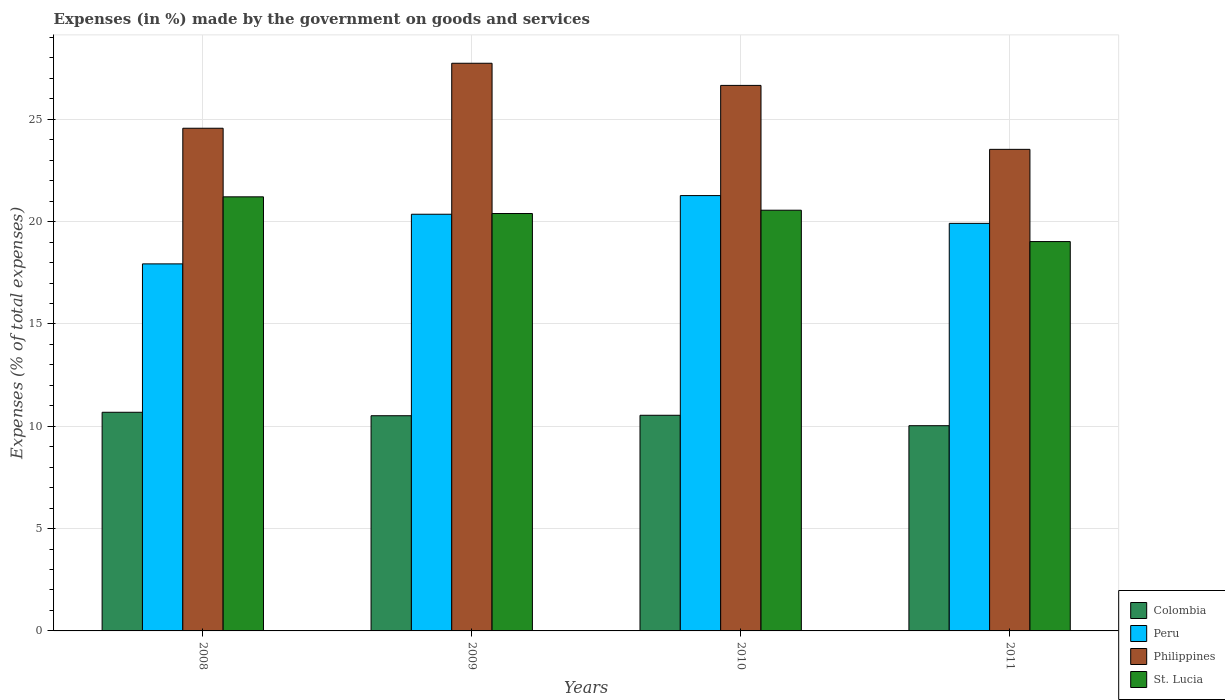Are the number of bars per tick equal to the number of legend labels?
Give a very brief answer. Yes. How many bars are there on the 1st tick from the left?
Your answer should be very brief. 4. How many bars are there on the 4th tick from the right?
Keep it short and to the point. 4. What is the label of the 4th group of bars from the left?
Provide a succinct answer. 2011. What is the percentage of expenses made by the government on goods and services in Colombia in 2008?
Provide a succinct answer. 10.69. Across all years, what is the maximum percentage of expenses made by the government on goods and services in Peru?
Your answer should be very brief. 21.28. Across all years, what is the minimum percentage of expenses made by the government on goods and services in Philippines?
Offer a very short reply. 23.54. What is the total percentage of expenses made by the government on goods and services in Peru in the graph?
Your response must be concise. 79.5. What is the difference between the percentage of expenses made by the government on goods and services in Philippines in 2009 and that in 2011?
Offer a very short reply. 4.21. What is the difference between the percentage of expenses made by the government on goods and services in Peru in 2011 and the percentage of expenses made by the government on goods and services in St. Lucia in 2010?
Provide a short and direct response. -0.64. What is the average percentage of expenses made by the government on goods and services in St. Lucia per year?
Provide a succinct answer. 20.3. In the year 2008, what is the difference between the percentage of expenses made by the government on goods and services in Philippines and percentage of expenses made by the government on goods and services in St. Lucia?
Your response must be concise. 3.35. In how many years, is the percentage of expenses made by the government on goods and services in Colombia greater than 17 %?
Provide a short and direct response. 0. What is the ratio of the percentage of expenses made by the government on goods and services in St. Lucia in 2008 to that in 2011?
Offer a terse response. 1.11. Is the percentage of expenses made by the government on goods and services in Colombia in 2008 less than that in 2009?
Offer a terse response. No. What is the difference between the highest and the second highest percentage of expenses made by the government on goods and services in Peru?
Provide a succinct answer. 0.91. What is the difference between the highest and the lowest percentage of expenses made by the government on goods and services in Philippines?
Your answer should be compact. 4.21. In how many years, is the percentage of expenses made by the government on goods and services in Peru greater than the average percentage of expenses made by the government on goods and services in Peru taken over all years?
Your response must be concise. 3. Is the sum of the percentage of expenses made by the government on goods and services in Peru in 2008 and 2010 greater than the maximum percentage of expenses made by the government on goods and services in St. Lucia across all years?
Keep it short and to the point. Yes. What does the 3rd bar from the right in 2008 represents?
Provide a short and direct response. Peru. Is it the case that in every year, the sum of the percentage of expenses made by the government on goods and services in Philippines and percentage of expenses made by the government on goods and services in St. Lucia is greater than the percentage of expenses made by the government on goods and services in Peru?
Make the answer very short. Yes. Are all the bars in the graph horizontal?
Offer a terse response. No. How many years are there in the graph?
Ensure brevity in your answer.  4. Does the graph contain any zero values?
Offer a very short reply. No. How many legend labels are there?
Keep it short and to the point. 4. What is the title of the graph?
Keep it short and to the point. Expenses (in %) made by the government on goods and services. What is the label or title of the Y-axis?
Make the answer very short. Expenses (% of total expenses). What is the Expenses (% of total expenses) in Colombia in 2008?
Your answer should be very brief. 10.69. What is the Expenses (% of total expenses) in Peru in 2008?
Offer a very short reply. 17.94. What is the Expenses (% of total expenses) in Philippines in 2008?
Your answer should be compact. 24.57. What is the Expenses (% of total expenses) of St. Lucia in 2008?
Offer a very short reply. 21.21. What is the Expenses (% of total expenses) of Colombia in 2009?
Your answer should be very brief. 10.52. What is the Expenses (% of total expenses) of Peru in 2009?
Give a very brief answer. 20.36. What is the Expenses (% of total expenses) of Philippines in 2009?
Provide a succinct answer. 27.74. What is the Expenses (% of total expenses) of St. Lucia in 2009?
Your answer should be compact. 20.4. What is the Expenses (% of total expenses) in Colombia in 2010?
Provide a short and direct response. 10.54. What is the Expenses (% of total expenses) of Peru in 2010?
Provide a short and direct response. 21.28. What is the Expenses (% of total expenses) of Philippines in 2010?
Your answer should be compact. 26.66. What is the Expenses (% of total expenses) in St. Lucia in 2010?
Offer a very short reply. 20.56. What is the Expenses (% of total expenses) of Colombia in 2011?
Your answer should be very brief. 10.03. What is the Expenses (% of total expenses) of Peru in 2011?
Make the answer very short. 19.92. What is the Expenses (% of total expenses) in Philippines in 2011?
Provide a short and direct response. 23.54. What is the Expenses (% of total expenses) of St. Lucia in 2011?
Provide a succinct answer. 19.03. Across all years, what is the maximum Expenses (% of total expenses) of Colombia?
Keep it short and to the point. 10.69. Across all years, what is the maximum Expenses (% of total expenses) in Peru?
Offer a very short reply. 21.28. Across all years, what is the maximum Expenses (% of total expenses) of Philippines?
Provide a short and direct response. 27.74. Across all years, what is the maximum Expenses (% of total expenses) in St. Lucia?
Make the answer very short. 21.21. Across all years, what is the minimum Expenses (% of total expenses) in Colombia?
Ensure brevity in your answer.  10.03. Across all years, what is the minimum Expenses (% of total expenses) in Peru?
Provide a succinct answer. 17.94. Across all years, what is the minimum Expenses (% of total expenses) in Philippines?
Give a very brief answer. 23.54. Across all years, what is the minimum Expenses (% of total expenses) in St. Lucia?
Offer a terse response. 19.03. What is the total Expenses (% of total expenses) of Colombia in the graph?
Your answer should be very brief. 41.77. What is the total Expenses (% of total expenses) in Peru in the graph?
Offer a very short reply. 79.5. What is the total Expenses (% of total expenses) of Philippines in the graph?
Ensure brevity in your answer.  102.51. What is the total Expenses (% of total expenses) of St. Lucia in the graph?
Your answer should be compact. 81.2. What is the difference between the Expenses (% of total expenses) in Colombia in 2008 and that in 2009?
Your answer should be very brief. 0.17. What is the difference between the Expenses (% of total expenses) in Peru in 2008 and that in 2009?
Your answer should be very brief. -2.43. What is the difference between the Expenses (% of total expenses) of Philippines in 2008 and that in 2009?
Offer a very short reply. -3.18. What is the difference between the Expenses (% of total expenses) in St. Lucia in 2008 and that in 2009?
Make the answer very short. 0.82. What is the difference between the Expenses (% of total expenses) in Colombia in 2008 and that in 2010?
Give a very brief answer. 0.15. What is the difference between the Expenses (% of total expenses) of Peru in 2008 and that in 2010?
Offer a terse response. -3.34. What is the difference between the Expenses (% of total expenses) in Philippines in 2008 and that in 2010?
Ensure brevity in your answer.  -2.09. What is the difference between the Expenses (% of total expenses) of St. Lucia in 2008 and that in 2010?
Your response must be concise. 0.65. What is the difference between the Expenses (% of total expenses) in Colombia in 2008 and that in 2011?
Keep it short and to the point. 0.66. What is the difference between the Expenses (% of total expenses) of Peru in 2008 and that in 2011?
Make the answer very short. -1.98. What is the difference between the Expenses (% of total expenses) in Philippines in 2008 and that in 2011?
Keep it short and to the point. 1.03. What is the difference between the Expenses (% of total expenses) of St. Lucia in 2008 and that in 2011?
Your response must be concise. 2.19. What is the difference between the Expenses (% of total expenses) in Colombia in 2009 and that in 2010?
Give a very brief answer. -0.02. What is the difference between the Expenses (% of total expenses) of Peru in 2009 and that in 2010?
Offer a terse response. -0.91. What is the difference between the Expenses (% of total expenses) of Philippines in 2009 and that in 2010?
Ensure brevity in your answer.  1.08. What is the difference between the Expenses (% of total expenses) in St. Lucia in 2009 and that in 2010?
Ensure brevity in your answer.  -0.16. What is the difference between the Expenses (% of total expenses) in Colombia in 2009 and that in 2011?
Provide a short and direct response. 0.49. What is the difference between the Expenses (% of total expenses) of Peru in 2009 and that in 2011?
Provide a short and direct response. 0.45. What is the difference between the Expenses (% of total expenses) in Philippines in 2009 and that in 2011?
Make the answer very short. 4.21. What is the difference between the Expenses (% of total expenses) in St. Lucia in 2009 and that in 2011?
Your response must be concise. 1.37. What is the difference between the Expenses (% of total expenses) of Colombia in 2010 and that in 2011?
Your response must be concise. 0.51. What is the difference between the Expenses (% of total expenses) of Peru in 2010 and that in 2011?
Your answer should be compact. 1.36. What is the difference between the Expenses (% of total expenses) in Philippines in 2010 and that in 2011?
Provide a succinct answer. 3.13. What is the difference between the Expenses (% of total expenses) of St. Lucia in 2010 and that in 2011?
Provide a succinct answer. 1.53. What is the difference between the Expenses (% of total expenses) in Colombia in 2008 and the Expenses (% of total expenses) in Peru in 2009?
Provide a succinct answer. -9.68. What is the difference between the Expenses (% of total expenses) in Colombia in 2008 and the Expenses (% of total expenses) in Philippines in 2009?
Offer a terse response. -17.06. What is the difference between the Expenses (% of total expenses) of Colombia in 2008 and the Expenses (% of total expenses) of St. Lucia in 2009?
Ensure brevity in your answer.  -9.71. What is the difference between the Expenses (% of total expenses) of Peru in 2008 and the Expenses (% of total expenses) of Philippines in 2009?
Provide a short and direct response. -9.8. What is the difference between the Expenses (% of total expenses) in Peru in 2008 and the Expenses (% of total expenses) in St. Lucia in 2009?
Your answer should be very brief. -2.46. What is the difference between the Expenses (% of total expenses) in Philippines in 2008 and the Expenses (% of total expenses) in St. Lucia in 2009?
Your response must be concise. 4.17. What is the difference between the Expenses (% of total expenses) of Colombia in 2008 and the Expenses (% of total expenses) of Peru in 2010?
Ensure brevity in your answer.  -10.59. What is the difference between the Expenses (% of total expenses) of Colombia in 2008 and the Expenses (% of total expenses) of Philippines in 2010?
Offer a terse response. -15.98. What is the difference between the Expenses (% of total expenses) in Colombia in 2008 and the Expenses (% of total expenses) in St. Lucia in 2010?
Provide a short and direct response. -9.88. What is the difference between the Expenses (% of total expenses) of Peru in 2008 and the Expenses (% of total expenses) of Philippines in 2010?
Ensure brevity in your answer.  -8.72. What is the difference between the Expenses (% of total expenses) in Peru in 2008 and the Expenses (% of total expenses) in St. Lucia in 2010?
Your answer should be compact. -2.62. What is the difference between the Expenses (% of total expenses) in Philippines in 2008 and the Expenses (% of total expenses) in St. Lucia in 2010?
Your response must be concise. 4.01. What is the difference between the Expenses (% of total expenses) of Colombia in 2008 and the Expenses (% of total expenses) of Peru in 2011?
Provide a short and direct response. -9.23. What is the difference between the Expenses (% of total expenses) of Colombia in 2008 and the Expenses (% of total expenses) of Philippines in 2011?
Your response must be concise. -12.85. What is the difference between the Expenses (% of total expenses) in Colombia in 2008 and the Expenses (% of total expenses) in St. Lucia in 2011?
Keep it short and to the point. -8.34. What is the difference between the Expenses (% of total expenses) of Peru in 2008 and the Expenses (% of total expenses) of Philippines in 2011?
Provide a short and direct response. -5.6. What is the difference between the Expenses (% of total expenses) in Peru in 2008 and the Expenses (% of total expenses) in St. Lucia in 2011?
Your answer should be very brief. -1.09. What is the difference between the Expenses (% of total expenses) in Philippines in 2008 and the Expenses (% of total expenses) in St. Lucia in 2011?
Make the answer very short. 5.54. What is the difference between the Expenses (% of total expenses) of Colombia in 2009 and the Expenses (% of total expenses) of Peru in 2010?
Offer a very short reply. -10.76. What is the difference between the Expenses (% of total expenses) of Colombia in 2009 and the Expenses (% of total expenses) of Philippines in 2010?
Keep it short and to the point. -16.14. What is the difference between the Expenses (% of total expenses) of Colombia in 2009 and the Expenses (% of total expenses) of St. Lucia in 2010?
Offer a terse response. -10.04. What is the difference between the Expenses (% of total expenses) of Peru in 2009 and the Expenses (% of total expenses) of Philippines in 2010?
Provide a short and direct response. -6.3. What is the difference between the Expenses (% of total expenses) in Peru in 2009 and the Expenses (% of total expenses) in St. Lucia in 2010?
Your answer should be compact. -0.2. What is the difference between the Expenses (% of total expenses) of Philippines in 2009 and the Expenses (% of total expenses) of St. Lucia in 2010?
Make the answer very short. 7.18. What is the difference between the Expenses (% of total expenses) in Colombia in 2009 and the Expenses (% of total expenses) in Peru in 2011?
Keep it short and to the point. -9.4. What is the difference between the Expenses (% of total expenses) in Colombia in 2009 and the Expenses (% of total expenses) in Philippines in 2011?
Offer a very short reply. -13.02. What is the difference between the Expenses (% of total expenses) in Colombia in 2009 and the Expenses (% of total expenses) in St. Lucia in 2011?
Make the answer very short. -8.51. What is the difference between the Expenses (% of total expenses) of Peru in 2009 and the Expenses (% of total expenses) of Philippines in 2011?
Provide a succinct answer. -3.17. What is the difference between the Expenses (% of total expenses) of Peru in 2009 and the Expenses (% of total expenses) of St. Lucia in 2011?
Make the answer very short. 1.34. What is the difference between the Expenses (% of total expenses) of Philippines in 2009 and the Expenses (% of total expenses) of St. Lucia in 2011?
Your response must be concise. 8.71. What is the difference between the Expenses (% of total expenses) in Colombia in 2010 and the Expenses (% of total expenses) in Peru in 2011?
Keep it short and to the point. -9.38. What is the difference between the Expenses (% of total expenses) in Colombia in 2010 and the Expenses (% of total expenses) in Philippines in 2011?
Provide a succinct answer. -13. What is the difference between the Expenses (% of total expenses) in Colombia in 2010 and the Expenses (% of total expenses) in St. Lucia in 2011?
Offer a terse response. -8.49. What is the difference between the Expenses (% of total expenses) of Peru in 2010 and the Expenses (% of total expenses) of Philippines in 2011?
Make the answer very short. -2.26. What is the difference between the Expenses (% of total expenses) in Peru in 2010 and the Expenses (% of total expenses) in St. Lucia in 2011?
Keep it short and to the point. 2.25. What is the difference between the Expenses (% of total expenses) of Philippines in 2010 and the Expenses (% of total expenses) of St. Lucia in 2011?
Your answer should be very brief. 7.63. What is the average Expenses (% of total expenses) in Colombia per year?
Ensure brevity in your answer.  10.44. What is the average Expenses (% of total expenses) of Peru per year?
Your response must be concise. 19.87. What is the average Expenses (% of total expenses) of Philippines per year?
Provide a succinct answer. 25.63. What is the average Expenses (% of total expenses) of St. Lucia per year?
Ensure brevity in your answer.  20.3. In the year 2008, what is the difference between the Expenses (% of total expenses) of Colombia and Expenses (% of total expenses) of Peru?
Your answer should be very brief. -7.25. In the year 2008, what is the difference between the Expenses (% of total expenses) of Colombia and Expenses (% of total expenses) of Philippines?
Keep it short and to the point. -13.88. In the year 2008, what is the difference between the Expenses (% of total expenses) of Colombia and Expenses (% of total expenses) of St. Lucia?
Keep it short and to the point. -10.53. In the year 2008, what is the difference between the Expenses (% of total expenses) of Peru and Expenses (% of total expenses) of Philippines?
Ensure brevity in your answer.  -6.63. In the year 2008, what is the difference between the Expenses (% of total expenses) in Peru and Expenses (% of total expenses) in St. Lucia?
Offer a very short reply. -3.28. In the year 2008, what is the difference between the Expenses (% of total expenses) in Philippines and Expenses (% of total expenses) in St. Lucia?
Offer a very short reply. 3.35. In the year 2009, what is the difference between the Expenses (% of total expenses) in Colombia and Expenses (% of total expenses) in Peru?
Your answer should be compact. -9.85. In the year 2009, what is the difference between the Expenses (% of total expenses) in Colombia and Expenses (% of total expenses) in Philippines?
Offer a terse response. -17.23. In the year 2009, what is the difference between the Expenses (% of total expenses) in Colombia and Expenses (% of total expenses) in St. Lucia?
Provide a succinct answer. -9.88. In the year 2009, what is the difference between the Expenses (% of total expenses) of Peru and Expenses (% of total expenses) of Philippines?
Keep it short and to the point. -7.38. In the year 2009, what is the difference between the Expenses (% of total expenses) of Peru and Expenses (% of total expenses) of St. Lucia?
Provide a short and direct response. -0.03. In the year 2009, what is the difference between the Expenses (% of total expenses) in Philippines and Expenses (% of total expenses) in St. Lucia?
Provide a short and direct response. 7.34. In the year 2010, what is the difference between the Expenses (% of total expenses) of Colombia and Expenses (% of total expenses) of Peru?
Your answer should be compact. -10.74. In the year 2010, what is the difference between the Expenses (% of total expenses) in Colombia and Expenses (% of total expenses) in Philippines?
Offer a very short reply. -16.12. In the year 2010, what is the difference between the Expenses (% of total expenses) in Colombia and Expenses (% of total expenses) in St. Lucia?
Your response must be concise. -10.02. In the year 2010, what is the difference between the Expenses (% of total expenses) of Peru and Expenses (% of total expenses) of Philippines?
Make the answer very short. -5.39. In the year 2010, what is the difference between the Expenses (% of total expenses) in Peru and Expenses (% of total expenses) in St. Lucia?
Ensure brevity in your answer.  0.71. In the year 2010, what is the difference between the Expenses (% of total expenses) of Philippines and Expenses (% of total expenses) of St. Lucia?
Keep it short and to the point. 6.1. In the year 2011, what is the difference between the Expenses (% of total expenses) in Colombia and Expenses (% of total expenses) in Peru?
Keep it short and to the point. -9.89. In the year 2011, what is the difference between the Expenses (% of total expenses) in Colombia and Expenses (% of total expenses) in Philippines?
Your answer should be compact. -13.51. In the year 2011, what is the difference between the Expenses (% of total expenses) in Colombia and Expenses (% of total expenses) in St. Lucia?
Your answer should be very brief. -9. In the year 2011, what is the difference between the Expenses (% of total expenses) in Peru and Expenses (% of total expenses) in Philippines?
Offer a terse response. -3.62. In the year 2011, what is the difference between the Expenses (% of total expenses) of Peru and Expenses (% of total expenses) of St. Lucia?
Provide a succinct answer. 0.89. In the year 2011, what is the difference between the Expenses (% of total expenses) of Philippines and Expenses (% of total expenses) of St. Lucia?
Ensure brevity in your answer.  4.51. What is the ratio of the Expenses (% of total expenses) of Colombia in 2008 to that in 2009?
Your response must be concise. 1.02. What is the ratio of the Expenses (% of total expenses) of Peru in 2008 to that in 2009?
Ensure brevity in your answer.  0.88. What is the ratio of the Expenses (% of total expenses) in Philippines in 2008 to that in 2009?
Your answer should be compact. 0.89. What is the ratio of the Expenses (% of total expenses) of St. Lucia in 2008 to that in 2009?
Provide a succinct answer. 1.04. What is the ratio of the Expenses (% of total expenses) of Colombia in 2008 to that in 2010?
Provide a succinct answer. 1.01. What is the ratio of the Expenses (% of total expenses) of Peru in 2008 to that in 2010?
Provide a short and direct response. 0.84. What is the ratio of the Expenses (% of total expenses) in Philippines in 2008 to that in 2010?
Your response must be concise. 0.92. What is the ratio of the Expenses (% of total expenses) in St. Lucia in 2008 to that in 2010?
Provide a succinct answer. 1.03. What is the ratio of the Expenses (% of total expenses) of Colombia in 2008 to that in 2011?
Offer a very short reply. 1.07. What is the ratio of the Expenses (% of total expenses) of Peru in 2008 to that in 2011?
Your answer should be very brief. 0.9. What is the ratio of the Expenses (% of total expenses) of Philippines in 2008 to that in 2011?
Your response must be concise. 1.04. What is the ratio of the Expenses (% of total expenses) in St. Lucia in 2008 to that in 2011?
Your answer should be very brief. 1.11. What is the ratio of the Expenses (% of total expenses) of Peru in 2009 to that in 2010?
Your answer should be very brief. 0.96. What is the ratio of the Expenses (% of total expenses) in Philippines in 2009 to that in 2010?
Make the answer very short. 1.04. What is the ratio of the Expenses (% of total expenses) in Colombia in 2009 to that in 2011?
Provide a short and direct response. 1.05. What is the ratio of the Expenses (% of total expenses) of Peru in 2009 to that in 2011?
Provide a short and direct response. 1.02. What is the ratio of the Expenses (% of total expenses) in Philippines in 2009 to that in 2011?
Your response must be concise. 1.18. What is the ratio of the Expenses (% of total expenses) in St. Lucia in 2009 to that in 2011?
Offer a terse response. 1.07. What is the ratio of the Expenses (% of total expenses) in Colombia in 2010 to that in 2011?
Give a very brief answer. 1.05. What is the ratio of the Expenses (% of total expenses) of Peru in 2010 to that in 2011?
Make the answer very short. 1.07. What is the ratio of the Expenses (% of total expenses) of Philippines in 2010 to that in 2011?
Keep it short and to the point. 1.13. What is the ratio of the Expenses (% of total expenses) in St. Lucia in 2010 to that in 2011?
Offer a terse response. 1.08. What is the difference between the highest and the second highest Expenses (% of total expenses) in Colombia?
Give a very brief answer. 0.15. What is the difference between the highest and the second highest Expenses (% of total expenses) of Peru?
Offer a very short reply. 0.91. What is the difference between the highest and the second highest Expenses (% of total expenses) in Philippines?
Ensure brevity in your answer.  1.08. What is the difference between the highest and the second highest Expenses (% of total expenses) of St. Lucia?
Your response must be concise. 0.65. What is the difference between the highest and the lowest Expenses (% of total expenses) of Colombia?
Provide a short and direct response. 0.66. What is the difference between the highest and the lowest Expenses (% of total expenses) of Peru?
Offer a terse response. 3.34. What is the difference between the highest and the lowest Expenses (% of total expenses) in Philippines?
Provide a short and direct response. 4.21. What is the difference between the highest and the lowest Expenses (% of total expenses) of St. Lucia?
Make the answer very short. 2.19. 